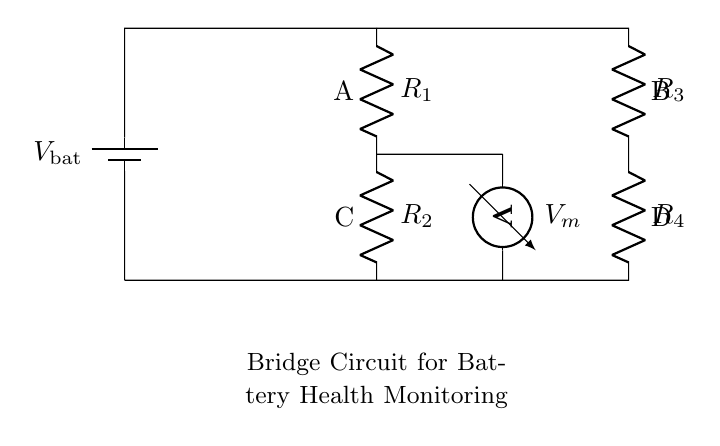What type of circuit is used for battery health monitoring? This circuit is a bridge circuit, specifically designed for comparing voltages and measuring the health of a battery in backup power systems.
Answer: Bridge circuit What do R1 and R2 represent in the diagram? R1 and R2 are resistors in the circuit that help create a voltage divider, which is essential for measuring the voltage across the battery.
Answer: Resistors How many resistors are present in the circuit? Upon analyzing the diagram, there are a total of four resistors indicated as R1, R2, R3, and R4.
Answer: Four What does V_m measure in the circuit? V_m signifies the voltage across the measuring points C and D, which is critical for assessing the battery's health.
Answer: Voltage Which component provides the input voltage to the circuit? The input voltage is supplied by the battery denoted as V_bat, which is located at the top left of the circuit.
Answer: Battery What is the configuration of the resistors R3 and R4 in the circuit? Resistors R3 and R4 are connected in series to a different branch of the bridge circuit, allowing for a comparison of voltage with R1 and R2.
Answer: Series 